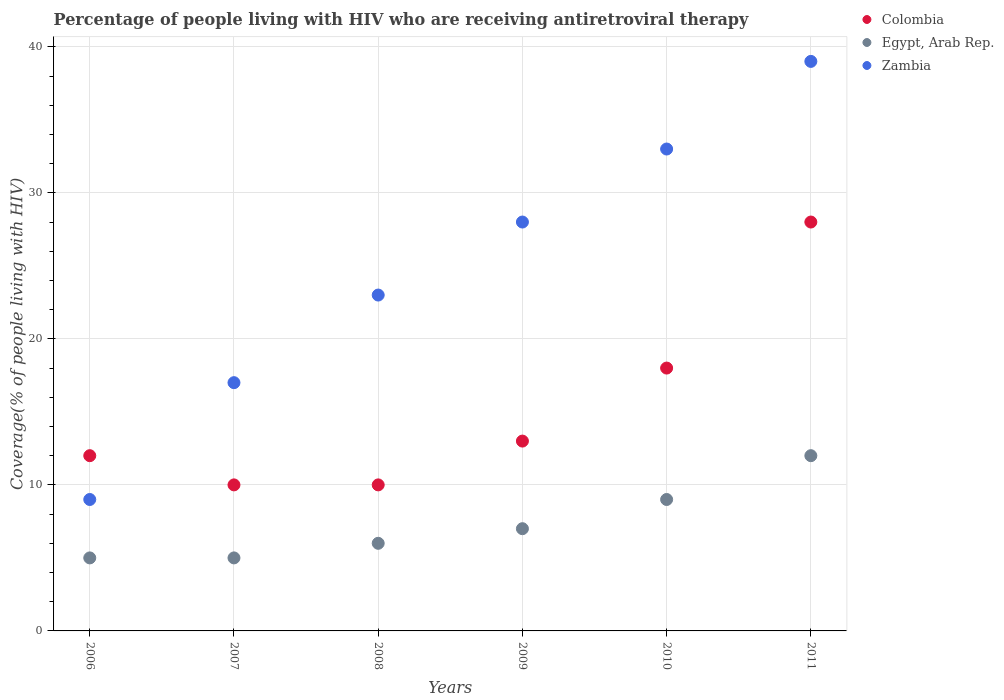What is the percentage of the HIV infected people who are receiving antiretroviral therapy in Zambia in 2006?
Your response must be concise. 9. Across all years, what is the maximum percentage of the HIV infected people who are receiving antiretroviral therapy in Egypt, Arab Rep.?
Make the answer very short. 12. Across all years, what is the minimum percentage of the HIV infected people who are receiving antiretroviral therapy in Colombia?
Make the answer very short. 10. In which year was the percentage of the HIV infected people who are receiving antiretroviral therapy in Zambia maximum?
Your response must be concise. 2011. In which year was the percentage of the HIV infected people who are receiving antiretroviral therapy in Colombia minimum?
Your answer should be compact. 2007. What is the total percentage of the HIV infected people who are receiving antiretroviral therapy in Colombia in the graph?
Your response must be concise. 91. What is the difference between the percentage of the HIV infected people who are receiving antiretroviral therapy in Colombia in 2007 and that in 2009?
Your answer should be very brief. -3. What is the difference between the percentage of the HIV infected people who are receiving antiretroviral therapy in Colombia in 2009 and the percentage of the HIV infected people who are receiving antiretroviral therapy in Zambia in 2008?
Your answer should be very brief. -10. What is the average percentage of the HIV infected people who are receiving antiretroviral therapy in Zambia per year?
Provide a short and direct response. 24.83. In the year 2011, what is the difference between the percentage of the HIV infected people who are receiving antiretroviral therapy in Zambia and percentage of the HIV infected people who are receiving antiretroviral therapy in Egypt, Arab Rep.?
Your answer should be very brief. 27. In how many years, is the percentage of the HIV infected people who are receiving antiretroviral therapy in Zambia greater than 38 %?
Your answer should be compact. 1. What is the ratio of the percentage of the HIV infected people who are receiving antiretroviral therapy in Colombia in 2006 to that in 2007?
Your answer should be very brief. 1.2. Is the percentage of the HIV infected people who are receiving antiretroviral therapy in Zambia in 2006 less than that in 2007?
Your response must be concise. Yes. What is the difference between the highest and the lowest percentage of the HIV infected people who are receiving antiretroviral therapy in Colombia?
Offer a terse response. 18. Is it the case that in every year, the sum of the percentage of the HIV infected people who are receiving antiretroviral therapy in Colombia and percentage of the HIV infected people who are receiving antiretroviral therapy in Zambia  is greater than the percentage of the HIV infected people who are receiving antiretroviral therapy in Egypt, Arab Rep.?
Provide a short and direct response. Yes. Does the percentage of the HIV infected people who are receiving antiretroviral therapy in Egypt, Arab Rep. monotonically increase over the years?
Your answer should be compact. No. How many years are there in the graph?
Give a very brief answer. 6. What is the difference between two consecutive major ticks on the Y-axis?
Give a very brief answer. 10. Are the values on the major ticks of Y-axis written in scientific E-notation?
Ensure brevity in your answer.  No. Does the graph contain grids?
Your answer should be very brief. Yes. Where does the legend appear in the graph?
Your answer should be very brief. Top right. What is the title of the graph?
Give a very brief answer. Percentage of people living with HIV who are receiving antiretroviral therapy. Does "Bolivia" appear as one of the legend labels in the graph?
Provide a succinct answer. No. What is the label or title of the X-axis?
Give a very brief answer. Years. What is the label or title of the Y-axis?
Offer a terse response. Coverage(% of people living with HIV). What is the Coverage(% of people living with HIV) of Colombia in 2006?
Keep it short and to the point. 12. What is the Coverage(% of people living with HIV) in Egypt, Arab Rep. in 2006?
Provide a short and direct response. 5. What is the Coverage(% of people living with HIV) in Zambia in 2007?
Your answer should be compact. 17. What is the Coverage(% of people living with HIV) in Colombia in 2008?
Offer a very short reply. 10. What is the Coverage(% of people living with HIV) of Zambia in 2008?
Your answer should be compact. 23. What is the Coverage(% of people living with HIV) in Egypt, Arab Rep. in 2009?
Make the answer very short. 7. What is the Coverage(% of people living with HIV) of Zambia in 2009?
Provide a succinct answer. 28. What is the Coverage(% of people living with HIV) of Egypt, Arab Rep. in 2010?
Provide a short and direct response. 9. What is the Coverage(% of people living with HIV) in Colombia in 2011?
Offer a terse response. 28. What is the Coverage(% of people living with HIV) of Egypt, Arab Rep. in 2011?
Your answer should be very brief. 12. Across all years, what is the maximum Coverage(% of people living with HIV) in Colombia?
Keep it short and to the point. 28. Across all years, what is the minimum Coverage(% of people living with HIV) of Zambia?
Your response must be concise. 9. What is the total Coverage(% of people living with HIV) in Colombia in the graph?
Your response must be concise. 91. What is the total Coverage(% of people living with HIV) of Egypt, Arab Rep. in the graph?
Provide a short and direct response. 44. What is the total Coverage(% of people living with HIV) of Zambia in the graph?
Make the answer very short. 149. What is the difference between the Coverage(% of people living with HIV) in Egypt, Arab Rep. in 2006 and that in 2007?
Your response must be concise. 0. What is the difference between the Coverage(% of people living with HIV) in Zambia in 2006 and that in 2007?
Provide a succinct answer. -8. What is the difference between the Coverage(% of people living with HIV) in Egypt, Arab Rep. in 2006 and that in 2008?
Give a very brief answer. -1. What is the difference between the Coverage(% of people living with HIV) in Zambia in 2006 and that in 2008?
Offer a terse response. -14. What is the difference between the Coverage(% of people living with HIV) in Colombia in 2006 and that in 2011?
Provide a succinct answer. -16. What is the difference between the Coverage(% of people living with HIV) of Egypt, Arab Rep. in 2006 and that in 2011?
Provide a short and direct response. -7. What is the difference between the Coverage(% of people living with HIV) in Zambia in 2006 and that in 2011?
Offer a very short reply. -30. What is the difference between the Coverage(% of people living with HIV) in Egypt, Arab Rep. in 2007 and that in 2008?
Make the answer very short. -1. What is the difference between the Coverage(% of people living with HIV) in Colombia in 2007 and that in 2009?
Ensure brevity in your answer.  -3. What is the difference between the Coverage(% of people living with HIV) in Egypt, Arab Rep. in 2007 and that in 2009?
Ensure brevity in your answer.  -2. What is the difference between the Coverage(% of people living with HIV) of Zambia in 2007 and that in 2009?
Give a very brief answer. -11. What is the difference between the Coverage(% of people living with HIV) of Zambia in 2007 and that in 2010?
Give a very brief answer. -16. What is the difference between the Coverage(% of people living with HIV) of Egypt, Arab Rep. in 2007 and that in 2011?
Make the answer very short. -7. What is the difference between the Coverage(% of people living with HIV) of Zambia in 2007 and that in 2011?
Provide a succinct answer. -22. What is the difference between the Coverage(% of people living with HIV) of Colombia in 2008 and that in 2009?
Make the answer very short. -3. What is the difference between the Coverage(% of people living with HIV) of Egypt, Arab Rep. in 2008 and that in 2009?
Your response must be concise. -1. What is the difference between the Coverage(% of people living with HIV) in Colombia in 2008 and that in 2010?
Provide a short and direct response. -8. What is the difference between the Coverage(% of people living with HIV) of Colombia in 2008 and that in 2011?
Offer a terse response. -18. What is the difference between the Coverage(% of people living with HIV) in Egypt, Arab Rep. in 2008 and that in 2011?
Provide a succinct answer. -6. What is the difference between the Coverage(% of people living with HIV) in Colombia in 2009 and that in 2011?
Make the answer very short. -15. What is the difference between the Coverage(% of people living with HIV) in Colombia in 2010 and that in 2011?
Your response must be concise. -10. What is the difference between the Coverage(% of people living with HIV) in Egypt, Arab Rep. in 2010 and that in 2011?
Give a very brief answer. -3. What is the difference between the Coverage(% of people living with HIV) in Zambia in 2010 and that in 2011?
Offer a terse response. -6. What is the difference between the Coverage(% of people living with HIV) of Colombia in 2006 and the Coverage(% of people living with HIV) of Egypt, Arab Rep. in 2007?
Give a very brief answer. 7. What is the difference between the Coverage(% of people living with HIV) in Egypt, Arab Rep. in 2006 and the Coverage(% of people living with HIV) in Zambia in 2007?
Offer a terse response. -12. What is the difference between the Coverage(% of people living with HIV) of Colombia in 2006 and the Coverage(% of people living with HIV) of Egypt, Arab Rep. in 2008?
Your answer should be compact. 6. What is the difference between the Coverage(% of people living with HIV) in Colombia in 2006 and the Coverage(% of people living with HIV) in Zambia in 2009?
Give a very brief answer. -16. What is the difference between the Coverage(% of people living with HIV) of Egypt, Arab Rep. in 2006 and the Coverage(% of people living with HIV) of Zambia in 2009?
Your response must be concise. -23. What is the difference between the Coverage(% of people living with HIV) in Colombia in 2006 and the Coverage(% of people living with HIV) in Egypt, Arab Rep. in 2010?
Your response must be concise. 3. What is the difference between the Coverage(% of people living with HIV) in Egypt, Arab Rep. in 2006 and the Coverage(% of people living with HIV) in Zambia in 2010?
Keep it short and to the point. -28. What is the difference between the Coverage(% of people living with HIV) in Colombia in 2006 and the Coverage(% of people living with HIV) in Zambia in 2011?
Give a very brief answer. -27. What is the difference between the Coverage(% of people living with HIV) of Egypt, Arab Rep. in 2006 and the Coverage(% of people living with HIV) of Zambia in 2011?
Make the answer very short. -34. What is the difference between the Coverage(% of people living with HIV) of Colombia in 2007 and the Coverage(% of people living with HIV) of Zambia in 2008?
Make the answer very short. -13. What is the difference between the Coverage(% of people living with HIV) of Egypt, Arab Rep. in 2007 and the Coverage(% of people living with HIV) of Zambia in 2008?
Make the answer very short. -18. What is the difference between the Coverage(% of people living with HIV) of Colombia in 2007 and the Coverage(% of people living with HIV) of Egypt, Arab Rep. in 2009?
Your answer should be very brief. 3. What is the difference between the Coverage(% of people living with HIV) of Colombia in 2007 and the Coverage(% of people living with HIV) of Zambia in 2009?
Keep it short and to the point. -18. What is the difference between the Coverage(% of people living with HIV) of Colombia in 2007 and the Coverage(% of people living with HIV) of Egypt, Arab Rep. in 2010?
Offer a terse response. 1. What is the difference between the Coverage(% of people living with HIV) of Egypt, Arab Rep. in 2007 and the Coverage(% of people living with HIV) of Zambia in 2010?
Your answer should be compact. -28. What is the difference between the Coverage(% of people living with HIV) of Colombia in 2007 and the Coverage(% of people living with HIV) of Egypt, Arab Rep. in 2011?
Provide a succinct answer. -2. What is the difference between the Coverage(% of people living with HIV) of Colombia in 2007 and the Coverage(% of people living with HIV) of Zambia in 2011?
Your answer should be compact. -29. What is the difference between the Coverage(% of people living with HIV) in Egypt, Arab Rep. in 2007 and the Coverage(% of people living with HIV) in Zambia in 2011?
Ensure brevity in your answer.  -34. What is the difference between the Coverage(% of people living with HIV) in Colombia in 2008 and the Coverage(% of people living with HIV) in Zambia in 2009?
Offer a terse response. -18. What is the difference between the Coverage(% of people living with HIV) of Egypt, Arab Rep. in 2008 and the Coverage(% of people living with HIV) of Zambia in 2009?
Ensure brevity in your answer.  -22. What is the difference between the Coverage(% of people living with HIV) in Colombia in 2008 and the Coverage(% of people living with HIV) in Egypt, Arab Rep. in 2010?
Make the answer very short. 1. What is the difference between the Coverage(% of people living with HIV) of Egypt, Arab Rep. in 2008 and the Coverage(% of people living with HIV) of Zambia in 2010?
Give a very brief answer. -27. What is the difference between the Coverage(% of people living with HIV) of Colombia in 2008 and the Coverage(% of people living with HIV) of Egypt, Arab Rep. in 2011?
Offer a very short reply. -2. What is the difference between the Coverage(% of people living with HIV) in Colombia in 2008 and the Coverage(% of people living with HIV) in Zambia in 2011?
Ensure brevity in your answer.  -29. What is the difference between the Coverage(% of people living with HIV) in Egypt, Arab Rep. in 2008 and the Coverage(% of people living with HIV) in Zambia in 2011?
Offer a terse response. -33. What is the difference between the Coverage(% of people living with HIV) of Colombia in 2009 and the Coverage(% of people living with HIV) of Zambia in 2010?
Provide a succinct answer. -20. What is the difference between the Coverage(% of people living with HIV) in Colombia in 2009 and the Coverage(% of people living with HIV) in Egypt, Arab Rep. in 2011?
Your response must be concise. 1. What is the difference between the Coverage(% of people living with HIV) of Colombia in 2009 and the Coverage(% of people living with HIV) of Zambia in 2011?
Keep it short and to the point. -26. What is the difference between the Coverage(% of people living with HIV) in Egypt, Arab Rep. in 2009 and the Coverage(% of people living with HIV) in Zambia in 2011?
Offer a terse response. -32. What is the difference between the Coverage(% of people living with HIV) in Colombia in 2010 and the Coverage(% of people living with HIV) in Egypt, Arab Rep. in 2011?
Your answer should be compact. 6. What is the difference between the Coverage(% of people living with HIV) in Colombia in 2010 and the Coverage(% of people living with HIV) in Zambia in 2011?
Provide a succinct answer. -21. What is the difference between the Coverage(% of people living with HIV) in Egypt, Arab Rep. in 2010 and the Coverage(% of people living with HIV) in Zambia in 2011?
Provide a succinct answer. -30. What is the average Coverage(% of people living with HIV) in Colombia per year?
Provide a succinct answer. 15.17. What is the average Coverage(% of people living with HIV) of Egypt, Arab Rep. per year?
Your answer should be very brief. 7.33. What is the average Coverage(% of people living with HIV) in Zambia per year?
Ensure brevity in your answer.  24.83. In the year 2006, what is the difference between the Coverage(% of people living with HIV) of Colombia and Coverage(% of people living with HIV) of Egypt, Arab Rep.?
Ensure brevity in your answer.  7. In the year 2006, what is the difference between the Coverage(% of people living with HIV) of Colombia and Coverage(% of people living with HIV) of Zambia?
Your answer should be compact. 3. In the year 2006, what is the difference between the Coverage(% of people living with HIV) of Egypt, Arab Rep. and Coverage(% of people living with HIV) of Zambia?
Provide a succinct answer. -4. In the year 2007, what is the difference between the Coverage(% of people living with HIV) of Colombia and Coverage(% of people living with HIV) of Egypt, Arab Rep.?
Your answer should be very brief. 5. In the year 2007, what is the difference between the Coverage(% of people living with HIV) of Colombia and Coverage(% of people living with HIV) of Zambia?
Keep it short and to the point. -7. In the year 2007, what is the difference between the Coverage(% of people living with HIV) in Egypt, Arab Rep. and Coverage(% of people living with HIV) in Zambia?
Your answer should be compact. -12. In the year 2008, what is the difference between the Coverage(% of people living with HIV) of Colombia and Coverage(% of people living with HIV) of Egypt, Arab Rep.?
Provide a succinct answer. 4. In the year 2008, what is the difference between the Coverage(% of people living with HIV) of Colombia and Coverage(% of people living with HIV) of Zambia?
Give a very brief answer. -13. In the year 2008, what is the difference between the Coverage(% of people living with HIV) in Egypt, Arab Rep. and Coverage(% of people living with HIV) in Zambia?
Make the answer very short. -17. In the year 2009, what is the difference between the Coverage(% of people living with HIV) of Colombia and Coverage(% of people living with HIV) of Zambia?
Provide a short and direct response. -15. In the year 2009, what is the difference between the Coverage(% of people living with HIV) of Egypt, Arab Rep. and Coverage(% of people living with HIV) of Zambia?
Give a very brief answer. -21. In the year 2011, what is the difference between the Coverage(% of people living with HIV) of Colombia and Coverage(% of people living with HIV) of Zambia?
Provide a short and direct response. -11. What is the ratio of the Coverage(% of people living with HIV) of Colombia in 2006 to that in 2007?
Provide a short and direct response. 1.2. What is the ratio of the Coverage(% of people living with HIV) in Zambia in 2006 to that in 2007?
Your answer should be compact. 0.53. What is the ratio of the Coverage(% of people living with HIV) of Colombia in 2006 to that in 2008?
Your answer should be very brief. 1.2. What is the ratio of the Coverage(% of people living with HIV) of Egypt, Arab Rep. in 2006 to that in 2008?
Give a very brief answer. 0.83. What is the ratio of the Coverage(% of people living with HIV) in Zambia in 2006 to that in 2008?
Provide a succinct answer. 0.39. What is the ratio of the Coverage(% of people living with HIV) in Colombia in 2006 to that in 2009?
Provide a succinct answer. 0.92. What is the ratio of the Coverage(% of people living with HIV) of Zambia in 2006 to that in 2009?
Ensure brevity in your answer.  0.32. What is the ratio of the Coverage(% of people living with HIV) in Colombia in 2006 to that in 2010?
Keep it short and to the point. 0.67. What is the ratio of the Coverage(% of people living with HIV) of Egypt, Arab Rep. in 2006 to that in 2010?
Ensure brevity in your answer.  0.56. What is the ratio of the Coverage(% of people living with HIV) in Zambia in 2006 to that in 2010?
Offer a terse response. 0.27. What is the ratio of the Coverage(% of people living with HIV) in Colombia in 2006 to that in 2011?
Make the answer very short. 0.43. What is the ratio of the Coverage(% of people living with HIV) of Egypt, Arab Rep. in 2006 to that in 2011?
Your answer should be very brief. 0.42. What is the ratio of the Coverage(% of people living with HIV) of Zambia in 2006 to that in 2011?
Your response must be concise. 0.23. What is the ratio of the Coverage(% of people living with HIV) of Zambia in 2007 to that in 2008?
Ensure brevity in your answer.  0.74. What is the ratio of the Coverage(% of people living with HIV) in Colombia in 2007 to that in 2009?
Ensure brevity in your answer.  0.77. What is the ratio of the Coverage(% of people living with HIV) in Egypt, Arab Rep. in 2007 to that in 2009?
Make the answer very short. 0.71. What is the ratio of the Coverage(% of people living with HIV) in Zambia in 2007 to that in 2009?
Your answer should be very brief. 0.61. What is the ratio of the Coverage(% of people living with HIV) of Colombia in 2007 to that in 2010?
Your answer should be very brief. 0.56. What is the ratio of the Coverage(% of people living with HIV) of Egypt, Arab Rep. in 2007 to that in 2010?
Your answer should be very brief. 0.56. What is the ratio of the Coverage(% of people living with HIV) of Zambia in 2007 to that in 2010?
Provide a succinct answer. 0.52. What is the ratio of the Coverage(% of people living with HIV) in Colombia in 2007 to that in 2011?
Make the answer very short. 0.36. What is the ratio of the Coverage(% of people living with HIV) in Egypt, Arab Rep. in 2007 to that in 2011?
Offer a very short reply. 0.42. What is the ratio of the Coverage(% of people living with HIV) in Zambia in 2007 to that in 2011?
Provide a short and direct response. 0.44. What is the ratio of the Coverage(% of people living with HIV) of Colombia in 2008 to that in 2009?
Make the answer very short. 0.77. What is the ratio of the Coverage(% of people living with HIV) of Egypt, Arab Rep. in 2008 to that in 2009?
Offer a very short reply. 0.86. What is the ratio of the Coverage(% of people living with HIV) in Zambia in 2008 to that in 2009?
Provide a succinct answer. 0.82. What is the ratio of the Coverage(% of people living with HIV) in Colombia in 2008 to that in 2010?
Your response must be concise. 0.56. What is the ratio of the Coverage(% of people living with HIV) of Zambia in 2008 to that in 2010?
Your response must be concise. 0.7. What is the ratio of the Coverage(% of people living with HIV) in Colombia in 2008 to that in 2011?
Make the answer very short. 0.36. What is the ratio of the Coverage(% of people living with HIV) in Egypt, Arab Rep. in 2008 to that in 2011?
Keep it short and to the point. 0.5. What is the ratio of the Coverage(% of people living with HIV) in Zambia in 2008 to that in 2011?
Ensure brevity in your answer.  0.59. What is the ratio of the Coverage(% of people living with HIV) in Colombia in 2009 to that in 2010?
Offer a very short reply. 0.72. What is the ratio of the Coverage(% of people living with HIV) of Egypt, Arab Rep. in 2009 to that in 2010?
Your answer should be compact. 0.78. What is the ratio of the Coverage(% of people living with HIV) of Zambia in 2009 to that in 2010?
Keep it short and to the point. 0.85. What is the ratio of the Coverage(% of people living with HIV) of Colombia in 2009 to that in 2011?
Make the answer very short. 0.46. What is the ratio of the Coverage(% of people living with HIV) of Egypt, Arab Rep. in 2009 to that in 2011?
Offer a terse response. 0.58. What is the ratio of the Coverage(% of people living with HIV) in Zambia in 2009 to that in 2011?
Make the answer very short. 0.72. What is the ratio of the Coverage(% of people living with HIV) of Colombia in 2010 to that in 2011?
Offer a very short reply. 0.64. What is the ratio of the Coverage(% of people living with HIV) of Zambia in 2010 to that in 2011?
Offer a terse response. 0.85. What is the difference between the highest and the second highest Coverage(% of people living with HIV) of Colombia?
Keep it short and to the point. 10. What is the difference between the highest and the second highest Coverage(% of people living with HIV) of Egypt, Arab Rep.?
Offer a terse response. 3. What is the difference between the highest and the second highest Coverage(% of people living with HIV) in Zambia?
Your answer should be very brief. 6. What is the difference between the highest and the lowest Coverage(% of people living with HIV) of Colombia?
Provide a short and direct response. 18. 